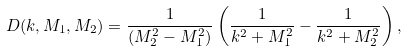Convert formula to latex. <formula><loc_0><loc_0><loc_500><loc_500>D ( k , M _ { 1 } , M _ { 2 } ) = \frac { 1 } { ( M _ { 2 } ^ { 2 } - M _ { 1 } ^ { 2 } ) } \left ( \frac { 1 } { k ^ { 2 } + M _ { 1 } ^ { 2 } } - \frac { 1 } { k ^ { 2 } + M _ { 2 } ^ { 2 } } \right ) ,</formula> 